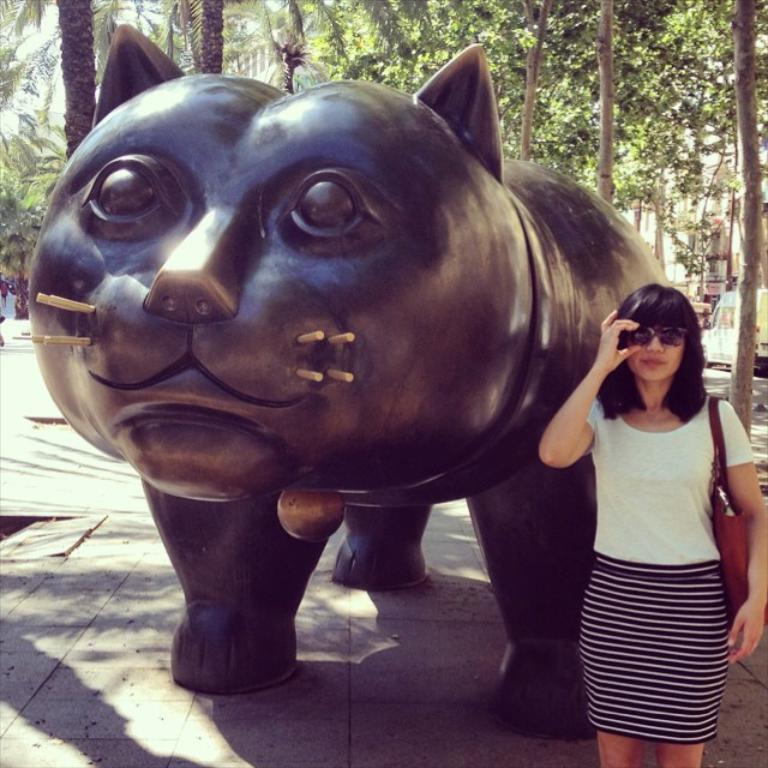In one or two sentences, can you explain what this image depicts? In this picture, we can see a statute of an animal and a person holding bag and sunglasses, we can see the ground, trees, buildings, vehicle and the sky. 